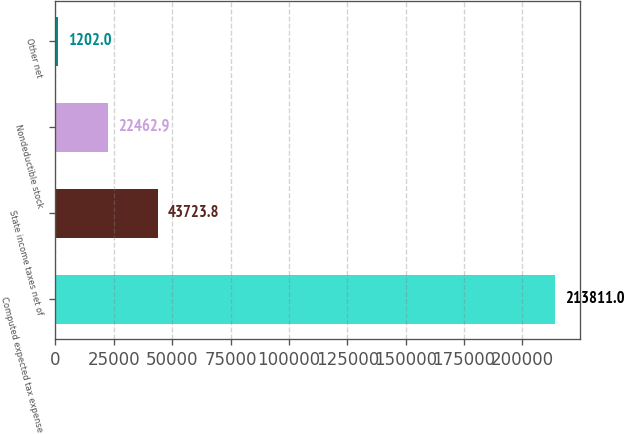Convert chart. <chart><loc_0><loc_0><loc_500><loc_500><bar_chart><fcel>Computed expected tax expense<fcel>State income taxes net of<fcel>Nondeductible stock<fcel>Other net<nl><fcel>213811<fcel>43723.8<fcel>22462.9<fcel>1202<nl></chart> 